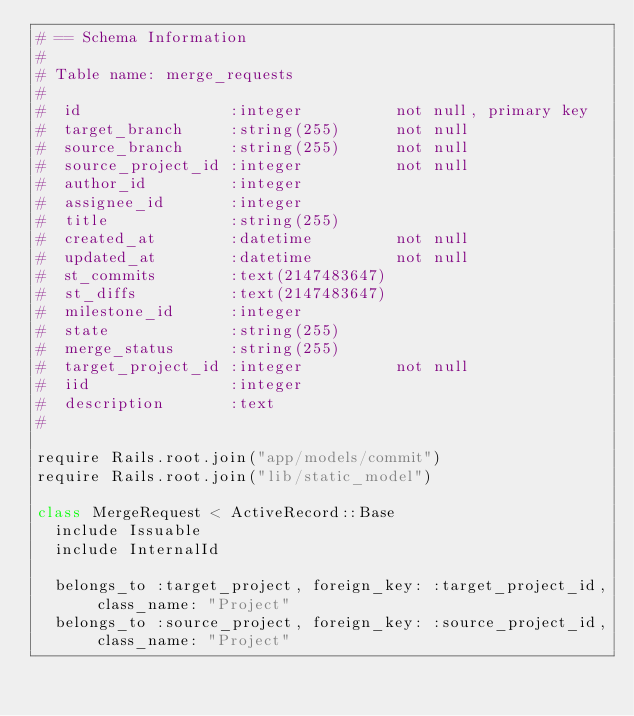Convert code to text. <code><loc_0><loc_0><loc_500><loc_500><_Ruby_># == Schema Information
#
# Table name: merge_requests
#
#  id                :integer          not null, primary key
#  target_branch     :string(255)      not null
#  source_branch     :string(255)      not null
#  source_project_id :integer          not null
#  author_id         :integer
#  assignee_id       :integer
#  title             :string(255)
#  created_at        :datetime         not null
#  updated_at        :datetime         not null
#  st_commits        :text(2147483647)
#  st_diffs          :text(2147483647)
#  milestone_id      :integer
#  state             :string(255)
#  merge_status      :string(255)
#  target_project_id :integer          not null
#  iid               :integer
#  description       :text
#

require Rails.root.join("app/models/commit")
require Rails.root.join("lib/static_model")

class MergeRequest < ActiveRecord::Base
  include Issuable
  include InternalId

  belongs_to :target_project, foreign_key: :target_project_id, class_name: "Project"
  belongs_to :source_project, foreign_key: :source_project_id, class_name: "Project"
</code> 